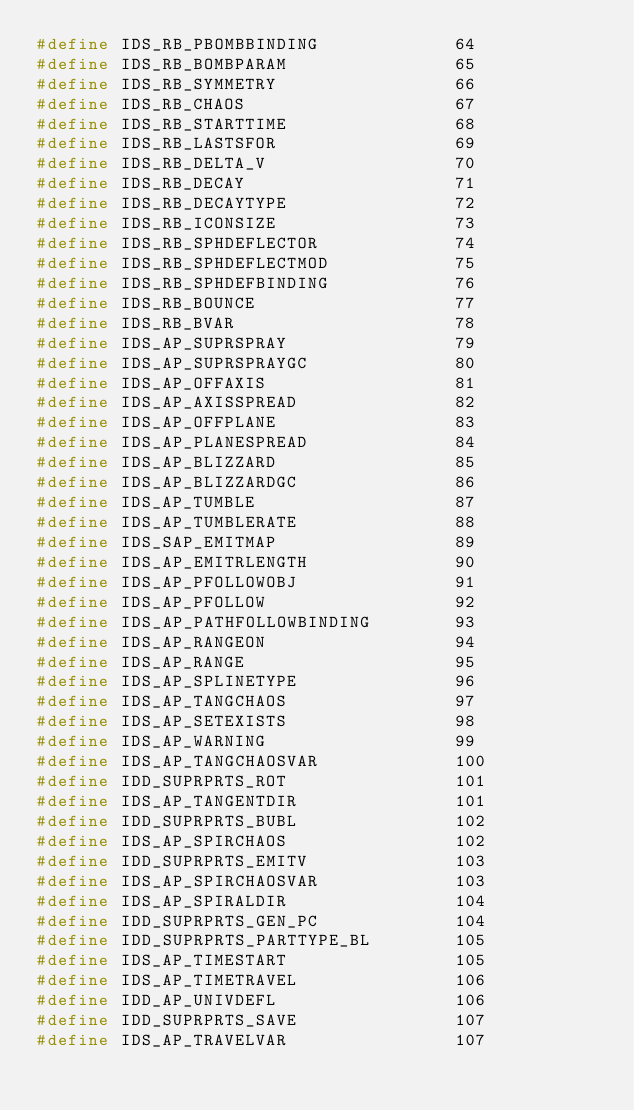<code> <loc_0><loc_0><loc_500><loc_500><_C_>#define IDS_RB_PBOMBBINDING             64
#define IDS_RB_BOMBPARAM                65
#define IDS_RB_SYMMETRY                 66
#define IDS_RB_CHAOS                    67
#define IDS_RB_STARTTIME                68
#define IDS_RB_LASTSFOR                 69
#define IDS_RB_DELTA_V                  70
#define IDS_RB_DECAY                    71
#define IDS_RB_DECAYTYPE                72
#define IDS_RB_ICONSIZE                 73
#define IDS_RB_SPHDEFLECTOR             74
#define IDS_RB_SPHDEFLECTMOD            75
#define IDS_RB_SPHDEFBINDING            76
#define IDS_RB_BOUNCE                   77
#define IDS_RB_BVAR                     78
#define IDS_AP_SUPRSPRAY                79
#define IDS_AP_SUPRSPRAYGC              80
#define IDS_AP_OFFAXIS                  81
#define IDS_AP_AXISSPREAD               82
#define IDS_AP_OFFPLANE                 83
#define IDS_AP_PLANESPREAD              84
#define IDS_AP_BLIZZARD                 85
#define IDS_AP_BLIZZARDGC               86
#define IDS_AP_TUMBLE                   87
#define IDS_AP_TUMBLERATE               88
#define IDS_SAP_EMITMAP                 89
#define IDS_AP_EMITRLENGTH              90
#define IDS_AP_PFOLLOWOBJ               91
#define IDS_AP_PFOLLOW                  92
#define IDS_AP_PATHFOLLOWBINDING        93
#define IDS_AP_RANGEON                  94
#define IDS_AP_RANGE                    95
#define IDS_AP_SPLINETYPE               96
#define IDS_AP_TANGCHAOS                97
#define IDS_AP_SETEXISTS                98
#define IDS_AP_WARNING                  99
#define IDS_AP_TANGCHAOSVAR             100
#define IDD_SUPRPRTS_ROT                101
#define IDS_AP_TANGENTDIR               101
#define IDD_SUPRPRTS_BUBL               102
#define IDS_AP_SPIRCHAOS                102
#define IDD_SUPRPRTS_EMITV              103
#define IDS_AP_SPIRCHAOSVAR             103
#define IDS_AP_SPIRALDIR                104
#define IDD_SUPRPRTS_GEN_PC             104
#define IDD_SUPRPRTS_PARTTYPE_BL        105
#define IDS_AP_TIMESTART                105
#define IDS_AP_TIMETRAVEL               106
#define IDD_AP_UNIVDEFL                 106
#define IDD_SUPRPRTS_SAVE               107
#define IDS_AP_TRAVELVAR                107</code> 